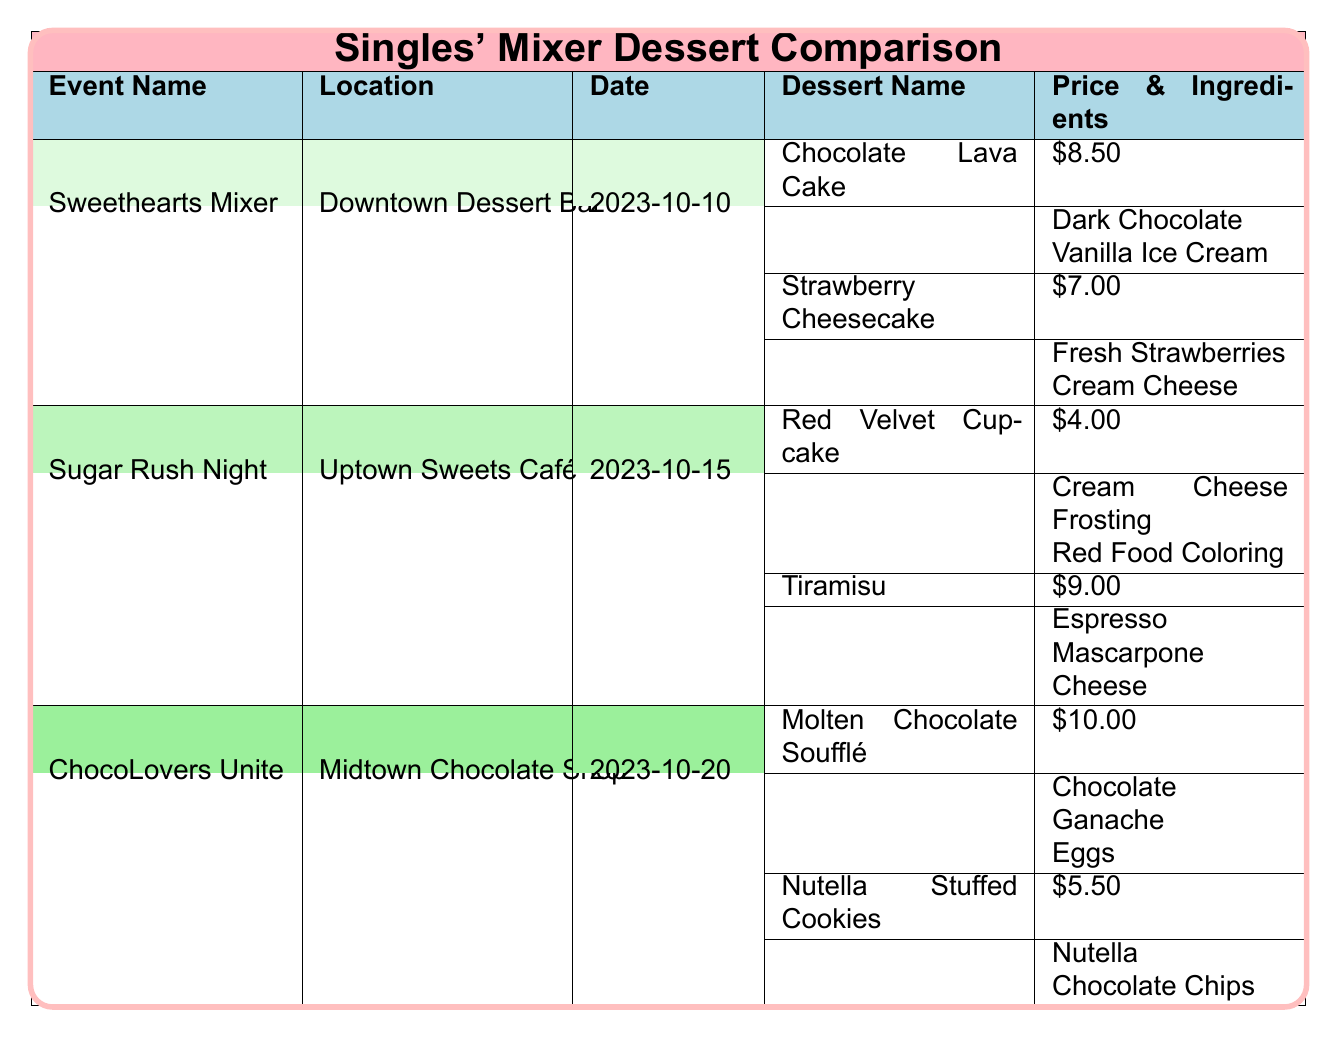What is the price of Strawberry Cheesecake at the Sweethearts Mixer? The table specifies that the Strawberry Cheesecake at the Sweethearts Mixer is priced at 7.00.
Answer: 7.00 Which event features the most expensive dessert? By comparing the dessert prices, the Molten Chocolate Soufflé at the ChocoLovers Unite event is priced at 10.00, which is higher than any other dessert prices listed.
Answer: ChocoLovers Unite How many desserts are priced at 5.50 or less? The desserts priced at 5.50 or less are the Red Velvet Cupcake (4.00) and Nutella Stuffed Cookies (5.50), totaling two desserts.
Answer: 2 Is the Tiramisu more expensive than the Chocolate Lava Cake? The price of Tiramisu is 9.00 and the Chocolate Lava Cake is 8.50. Since 9.00 is greater than 8.50, Tiramisu is indeed more expensive than the Chocolate Lava Cake.
Answer: Yes What is the total price of all desserts at the Sugar Rush Night? The two desserts at the Sugar Rush Night are the Red Velvet Cupcake (4.00) and Tiramisu (9.00). Summing these gives 4.00 + 9.00 = 13.00. Thus, the total price of all desserts is 13.00.
Answer: 13.00 Which dessert has a special ingredient of Vanilla Ice Cream? The Chocolate Lava Cake at the Sweethearts Mixer has a special ingredient of Vanilla Ice Cream, as indicated in the table.
Answer: Chocolate Lava Cake How many unique locations are mentioned in the events? The table lists three unique locations: Downtown Dessert Bar, Uptown Sweets Café, and Midtown Chocolate Shop. There are no repeats, making a total of three unique locations.
Answer: 3 What is the average price of desserts at the Sweethearts Mixer? The prices of the desserts at the Sweethearts Mixer are 8.50 (Chocolate Lava Cake) and 7.00 (Strawberry Cheesecake). The total price is 8.50 + 7.00 = 15.50. Dividing this by the number of desserts (2), we get an average price of 15.50 / 2 = 7.75.
Answer: 7.75 Which event has the highest-priced dessert and how much is it? The event with the highest-priced dessert is ChocoLovers Unite, where the Molten Chocolate Soufflé is priced at 10.00, the highest among all desserts listed.
Answer: 10.00 